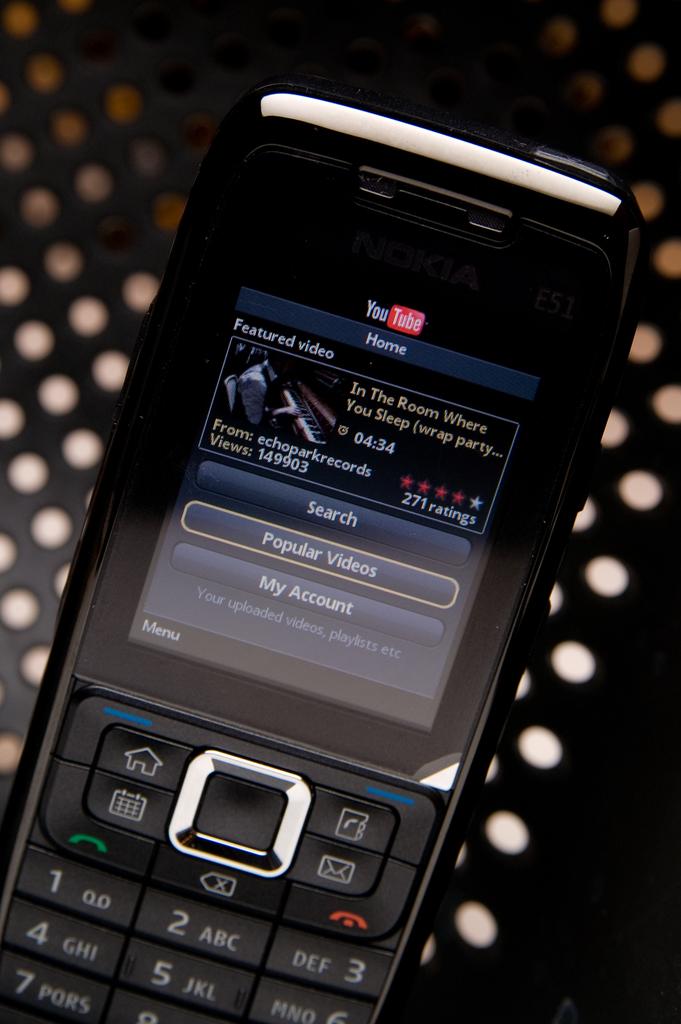What website are they on?
Offer a very short reply. Youtube. 